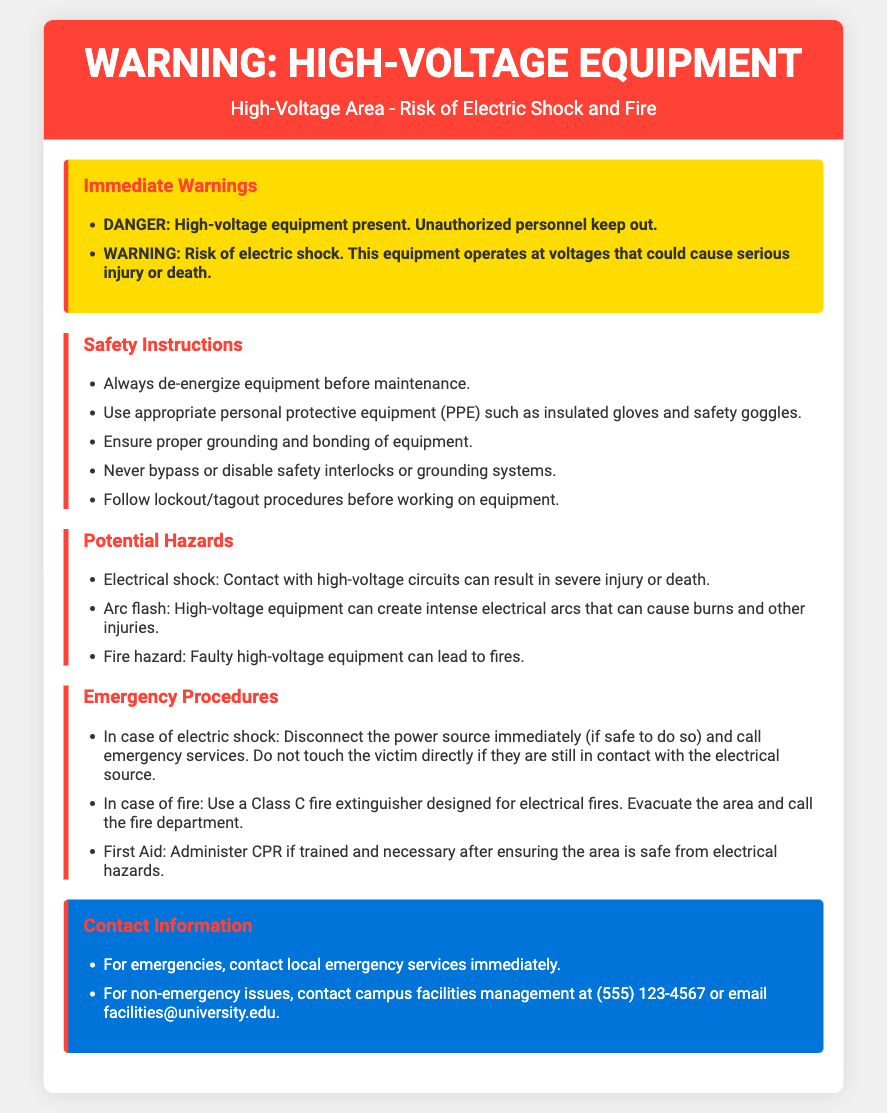What are the immediate warnings associated with high-voltage equipment? The immediate warnings include danger from high-voltage equipment and the risk of electric shock.
Answer: DANGER: High-voltage equipment present. Unauthorized personnel keep out. WARNING: Risk of electric shock What should you always do before maintaining high-voltage equipment? The safety instructions specify that equipment should be de-energized before maintenance.
Answer: Always de-energize equipment before maintenance What is a potential hazard of high-voltage equipment? The document lists electrical shock as one of the potential hazards.
Answer: Electrical shock What type of fire extinguisher should be used in case of an electrical fire? The emergency procedures state that a Class C fire extinguisher should be used.
Answer: Class C What is the emergency contact number for campus facilities management? The contact information section provides the contact number for non-emergency issues.
Answer: (555) 123-4567 